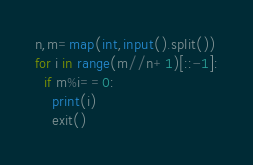Convert code to text. <code><loc_0><loc_0><loc_500><loc_500><_Python_>n,m=map(int,input().split())
for i in range(m//n+1)[::-1]:
  if m%i==0:
    print(i)
    exit()
</code> 